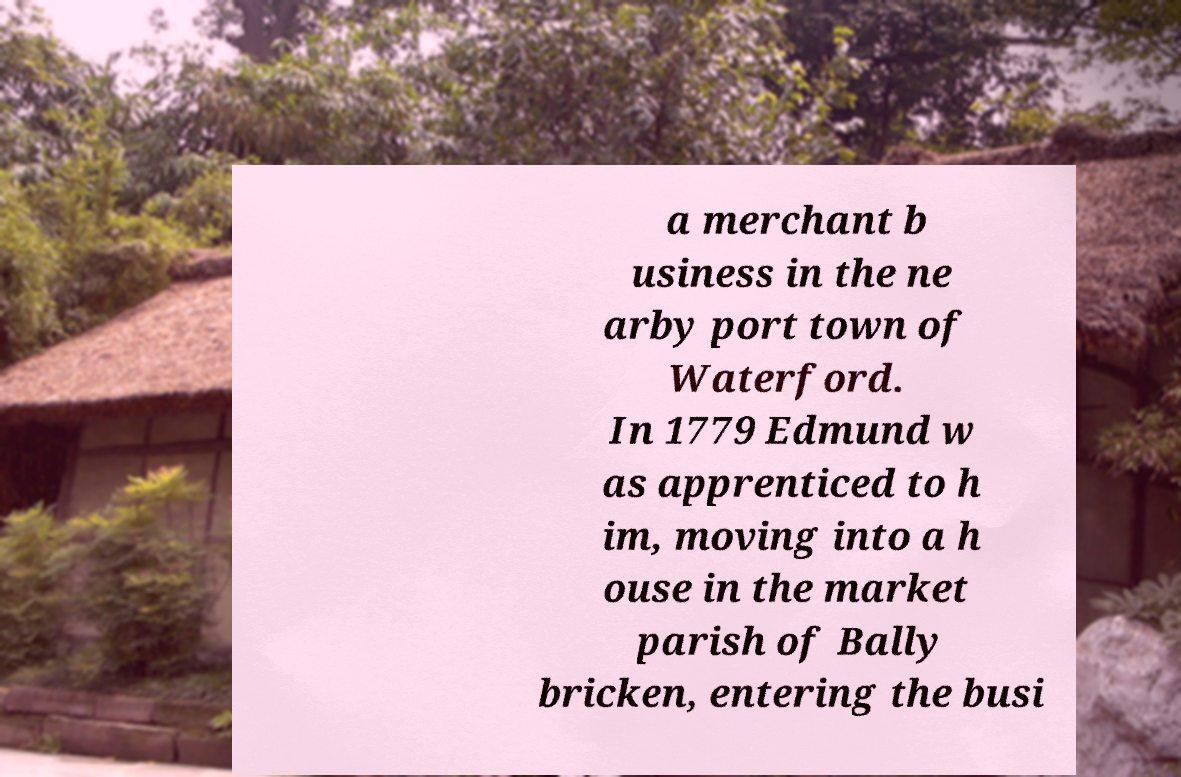Can you read and provide the text displayed in the image?This photo seems to have some interesting text. Can you extract and type it out for me? a merchant b usiness in the ne arby port town of Waterford. In 1779 Edmund w as apprenticed to h im, moving into a h ouse in the market parish of Bally bricken, entering the busi 